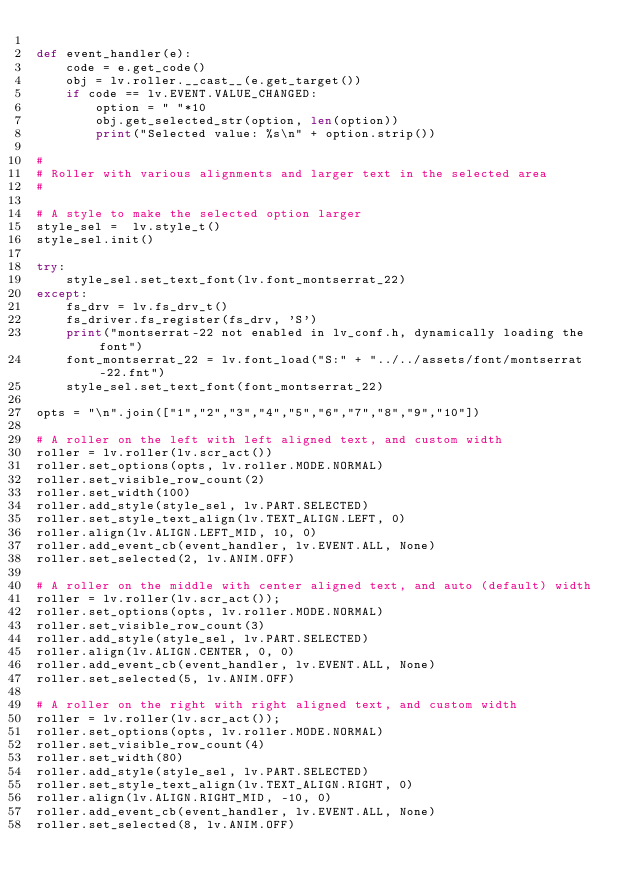Convert code to text. <code><loc_0><loc_0><loc_500><loc_500><_Python_>
def event_handler(e):
    code = e.get_code()
    obj = lv.roller.__cast__(e.get_target())
    if code == lv.EVENT.VALUE_CHANGED: 
        option = " "*10
        obj.get_selected_str(option, len(option))
        print("Selected value: %s\n" + option.strip())

#
# Roller with various alignments and larger text in the selected area
#

# A style to make the selected option larger
style_sel =  lv.style_t()
style_sel.init()

try:
    style_sel.set_text_font(lv.font_montserrat_22)
except:
    fs_drv = lv.fs_drv_t()
    fs_driver.fs_register(fs_drv, 'S')
    print("montserrat-22 not enabled in lv_conf.h, dynamically loading the font")
    font_montserrat_22 = lv.font_load("S:" + "../../assets/font/montserrat-22.fnt")
    style_sel.set_text_font(font_montserrat_22)
    
opts = "\n".join(["1","2","3","4","5","6","7","8","9","10"])

# A roller on the left with left aligned text, and custom width
roller = lv.roller(lv.scr_act())
roller.set_options(opts, lv.roller.MODE.NORMAL)
roller.set_visible_row_count(2)
roller.set_width(100)
roller.add_style(style_sel, lv.PART.SELECTED)
roller.set_style_text_align(lv.TEXT_ALIGN.LEFT, 0)
roller.align(lv.ALIGN.LEFT_MID, 10, 0)
roller.add_event_cb(event_handler, lv.EVENT.ALL, None)
roller.set_selected(2, lv.ANIM.OFF)

# A roller on the middle with center aligned text, and auto (default) width
roller = lv.roller(lv.scr_act());
roller.set_options(opts, lv.roller.MODE.NORMAL)
roller.set_visible_row_count(3)
roller.add_style(style_sel, lv.PART.SELECTED)
roller.align(lv.ALIGN.CENTER, 0, 0)
roller.add_event_cb(event_handler, lv.EVENT.ALL, None)
roller.set_selected(5, lv.ANIM.OFF)

# A roller on the right with right aligned text, and custom width
roller = lv.roller(lv.scr_act());
roller.set_options(opts, lv.roller.MODE.NORMAL)
roller.set_visible_row_count(4)
roller.set_width(80)
roller.add_style(style_sel, lv.PART.SELECTED)
roller.set_style_text_align(lv.TEXT_ALIGN.RIGHT, 0)
roller.align(lv.ALIGN.RIGHT_MID, -10, 0)
roller.add_event_cb(event_handler, lv.EVENT.ALL, None)
roller.set_selected(8, lv.ANIM.OFF)

</code> 